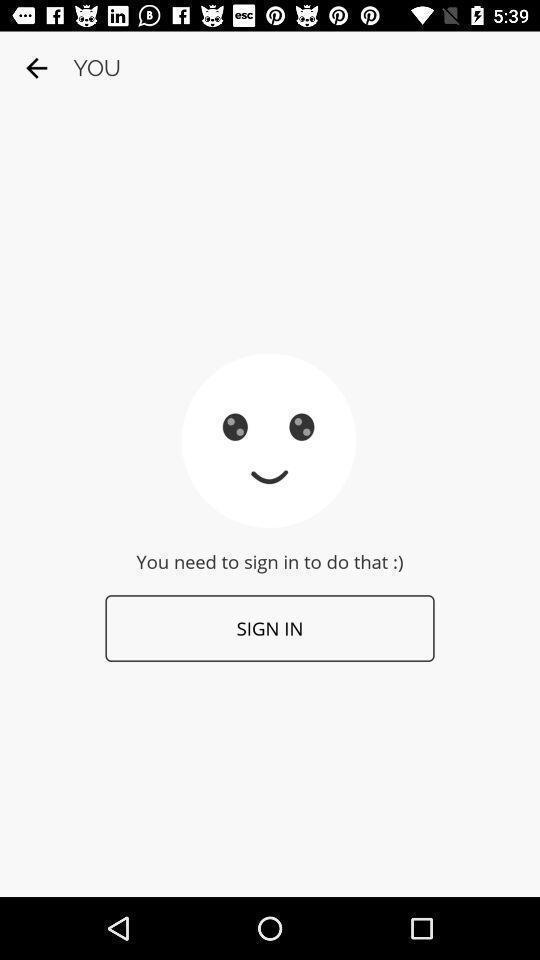Explain what's happening in this screen capture. Sign in page. 